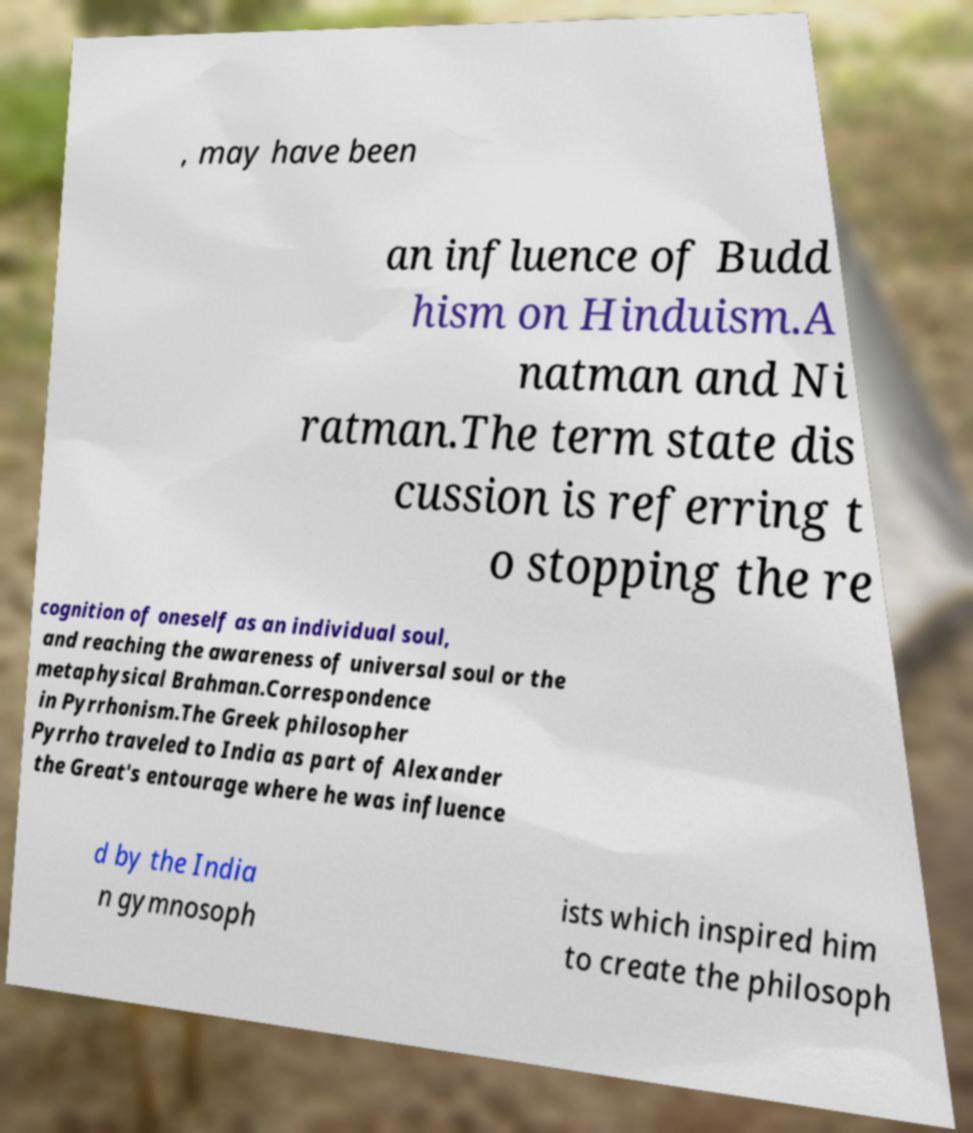I need the written content from this picture converted into text. Can you do that? , may have been an influence of Budd hism on Hinduism.A natman and Ni ratman.The term state dis cussion is referring t o stopping the re cognition of oneself as an individual soul, and reaching the awareness of universal soul or the metaphysical Brahman.Correspondence in Pyrrhonism.The Greek philosopher Pyrrho traveled to India as part of Alexander the Great's entourage where he was influence d by the India n gymnosoph ists which inspired him to create the philosoph 